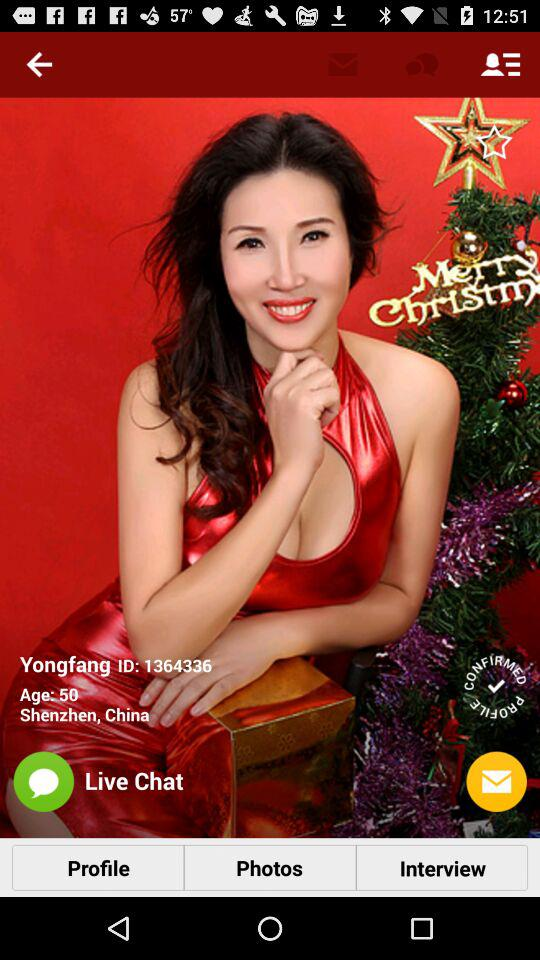How many photos are in the profile?
When the provided information is insufficient, respond with <no answer>. <no answer> 